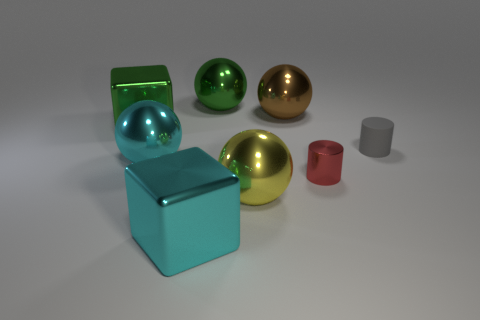What number of other objects are the same material as the red object?
Offer a very short reply. 6. Is the material of the big cube in front of the red thing the same as the red cylinder that is to the left of the small gray rubber object?
Keep it short and to the point. Yes. There is a brown thing that is made of the same material as the red cylinder; what is its shape?
Offer a terse response. Sphere. Is there anything else of the same color as the metal cylinder?
Give a very brief answer. No. How many big green metal things are there?
Ensure brevity in your answer.  2. What shape is the large thing that is on the right side of the cyan metal block and to the left of the yellow thing?
Offer a very short reply. Sphere. There is a big green thing right of the big block that is in front of the large metallic block that is on the left side of the cyan metallic block; what is its shape?
Give a very brief answer. Sphere. There is a object that is in front of the tiny gray thing and right of the brown object; what is its material?
Your answer should be compact. Metal. What number of green spheres have the same size as the shiny cylinder?
Provide a succinct answer. 0. What number of matte things are large cyan cylinders or big things?
Provide a succinct answer. 0. 